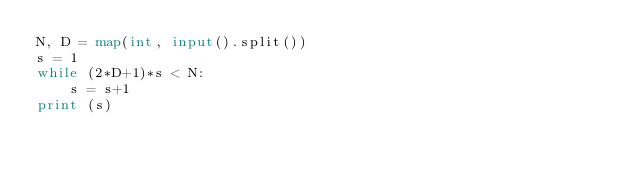<code> <loc_0><loc_0><loc_500><loc_500><_Python_>N, D = map(int, input().split())
s = 1
while (2*D+1)*s < N:
    s = s+1
print (s)</code> 